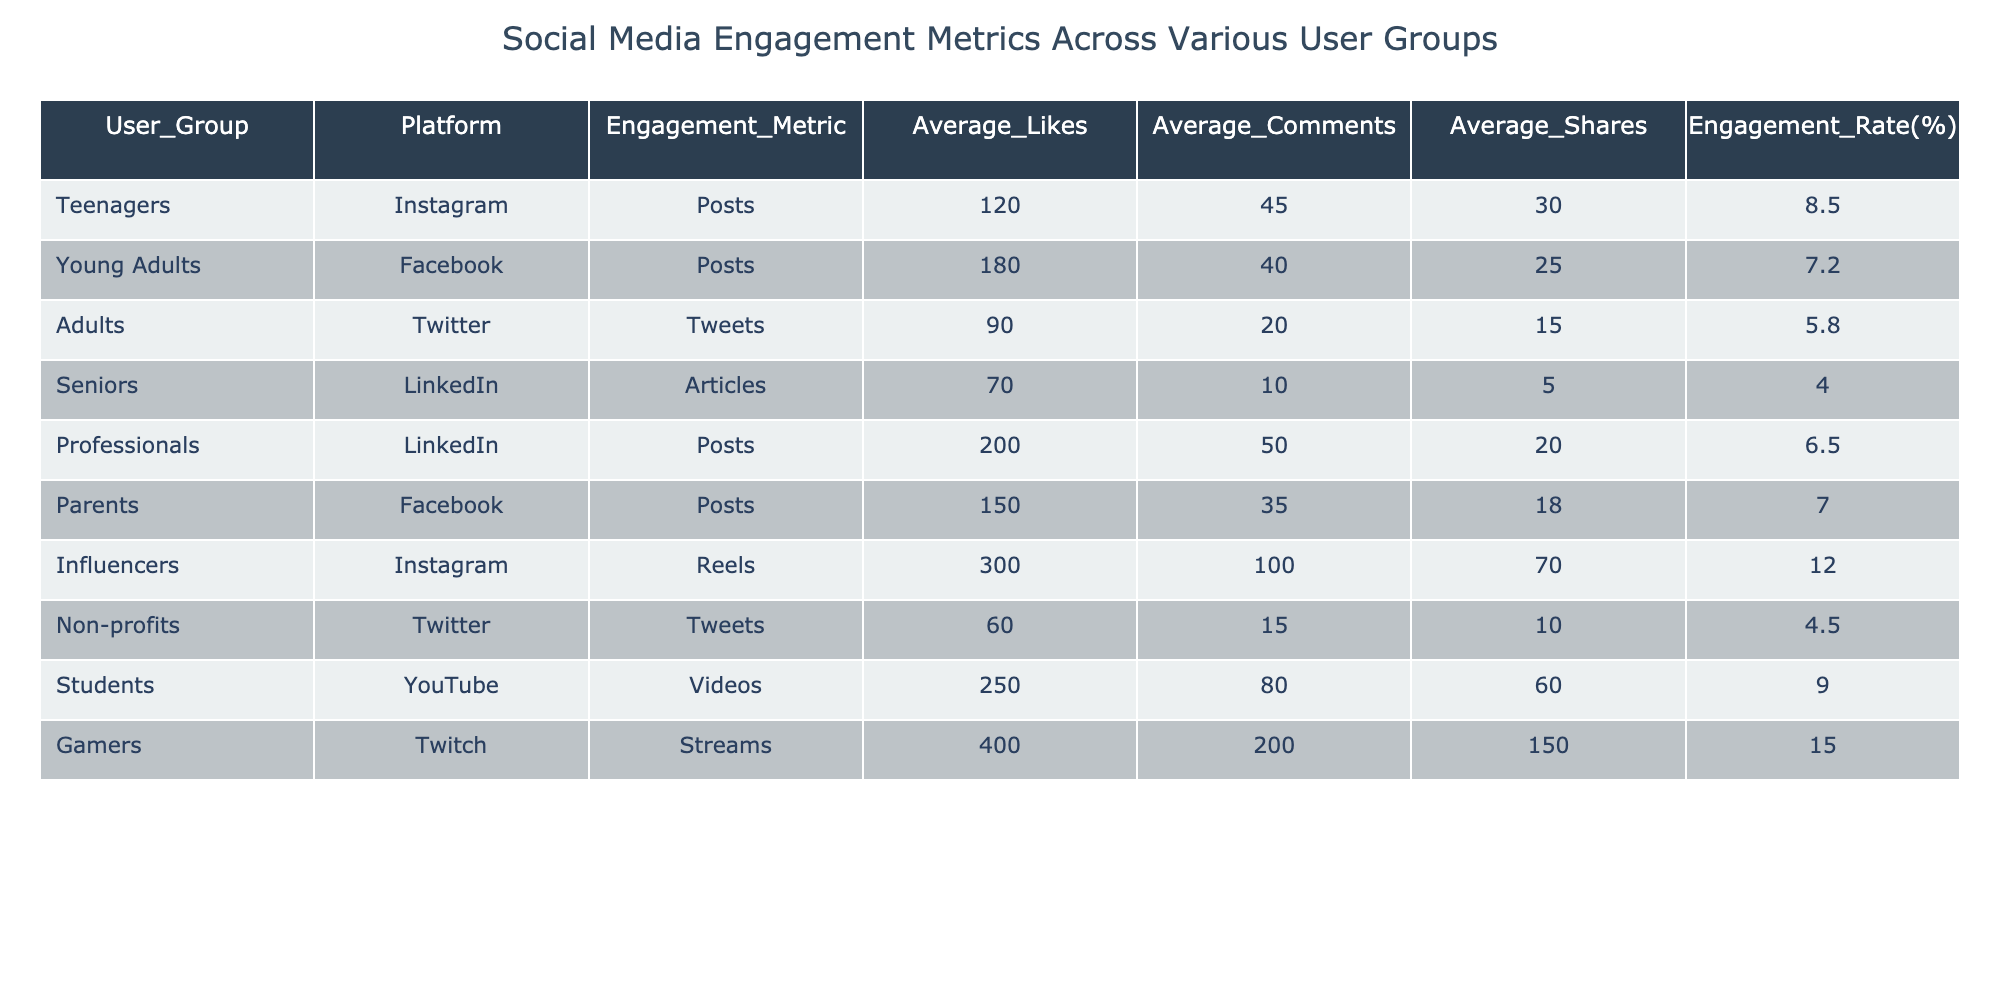What is the average number of likes for Influencers on Instagram? The table lists the average number of likes for Influencers on Instagram as 300. This can be directly retrieved from the corresponding row in the table.
Answer: 300 Which user group has the lowest average engagement rate? By examining the engagement rates in the table, Seniors have the lowest engagement rate at 4.0%, as indicated in their row.
Answer: 4.0% How many total shares do students receive on average across their YouTube videos and Gamers from Twitch streams? The average shares for Students on YouTube is 60 and for Gamers on Twitch is 150. Summing these values gives 60 + 150 = 210.
Answer: 210 Is the average number of comments for Parents higher than that for Adults? From the table, Parents have an average of 35 comments while Adults have 20 comments. Since 35 is greater than 20, the answer is yes.
Answer: Yes Which platform has the highest average shares according to the table? Looking at the table, Gamers' Twitch streams have the highest average shares at 150. The data in the table allows for an easy comparison of the average shares across platforms.
Answer: Twitch What is the engagement rate difference between Gamers on Twitch and Influencers on Instagram? Gamers have an engagement rate of 15.0% and Influencers have an engagement rate of 12.0%. To find the difference, we subtract: 15.0 - 12.0 = 3.0%.
Answer: 3.0% How many user groups have an average of over 200 likes? By checking the table, there are three user groups: Influencers with 300 likes, Professionals with 200 likes, and Gamers with 400 likes. Since they all meet the criteria, the answer is 3.
Answer: 3 Do both the average likes and average shares for Young Adults on Facebook exceed those of Parents? Young Adults have 180 likes and 25 shares, while Parents have 150 likes and 18 shares. Comparing both metrics, Young Adults exceed Parents in both categories, so the answer is yes.
Answer: Yes What is the average engagement rate among all user groups listed in the table? The engagement rates are 8.5, 7.2, 5.8, 4.0, 6.5, 7.0, 12.0, 4.5, 9.0, and 15.0. Adding them gives a total of 75.5. Dividing by 10 (the number of user groups) gives an average of 7.55%.
Answer: 7.55% 